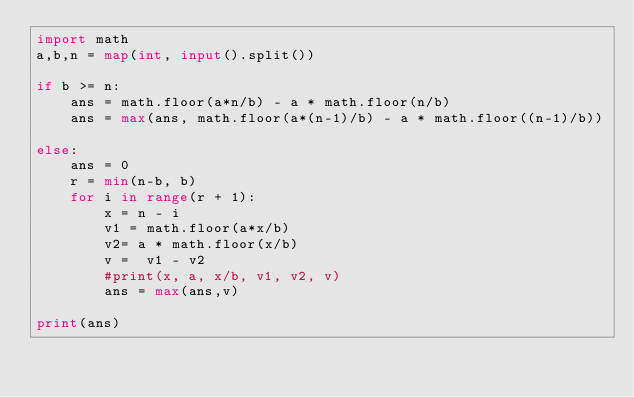Convert code to text. <code><loc_0><loc_0><loc_500><loc_500><_Python_>import math
a,b,n = map(int, input().split())

if b >= n:
    ans = math.floor(a*n/b) - a * math.floor(n/b)
    ans = max(ans, math.floor(a*(n-1)/b) - a * math.floor((n-1)/b))

else:
    ans = 0
    r = min(n-b, b)
    for i in range(r + 1):
        x = n - i
        v1 = math.floor(a*x/b)
        v2= a * math.floor(x/b)
        v =  v1 - v2
        #print(x, a, x/b, v1, v2, v)
        ans = max(ans,v)

print(ans)</code> 